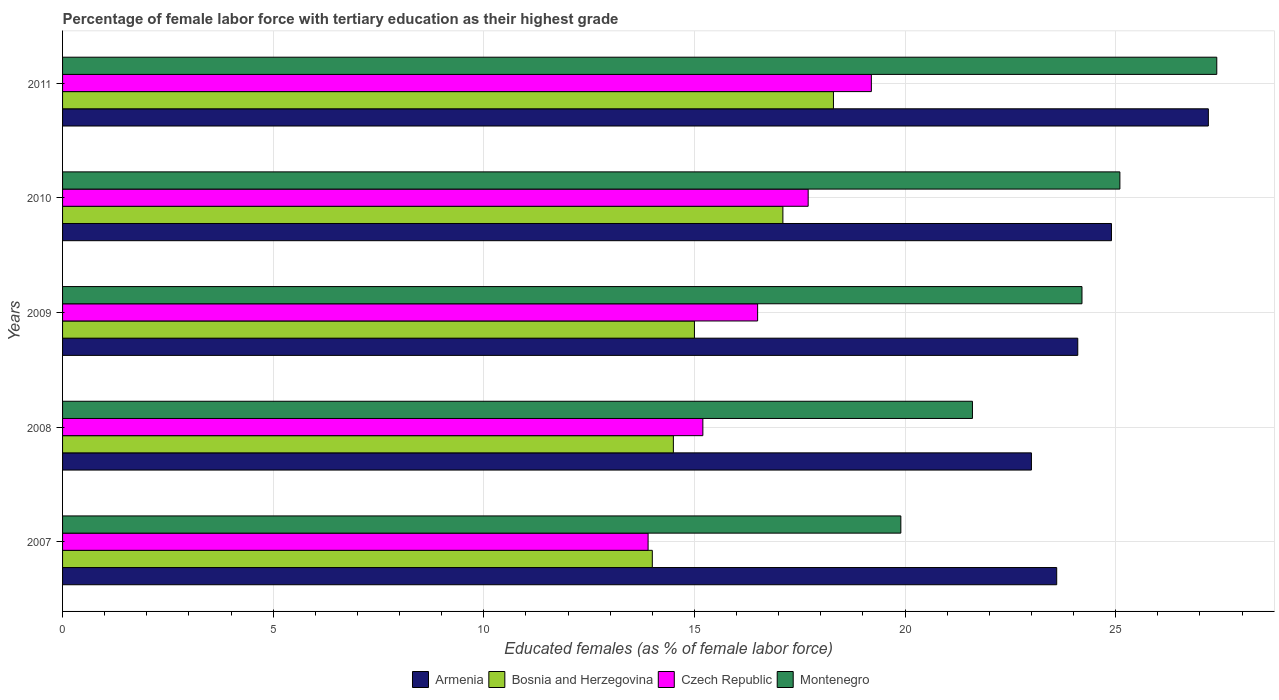How many different coloured bars are there?
Give a very brief answer. 4. What is the percentage of female labor force with tertiary education in Montenegro in 2009?
Offer a terse response. 24.2. Across all years, what is the maximum percentage of female labor force with tertiary education in Montenegro?
Your response must be concise. 27.4. In which year was the percentage of female labor force with tertiary education in Czech Republic maximum?
Make the answer very short. 2011. What is the total percentage of female labor force with tertiary education in Czech Republic in the graph?
Your response must be concise. 82.5. What is the average percentage of female labor force with tertiary education in Montenegro per year?
Your answer should be compact. 23.64. In the year 2011, what is the difference between the percentage of female labor force with tertiary education in Montenegro and percentage of female labor force with tertiary education in Armenia?
Offer a very short reply. 0.2. What is the ratio of the percentage of female labor force with tertiary education in Bosnia and Herzegovina in 2007 to that in 2011?
Keep it short and to the point. 0.77. What is the difference between the highest and the second highest percentage of female labor force with tertiary education in Bosnia and Herzegovina?
Your answer should be compact. 1.2. What is the difference between the highest and the lowest percentage of female labor force with tertiary education in Montenegro?
Make the answer very short. 7.5. In how many years, is the percentage of female labor force with tertiary education in Montenegro greater than the average percentage of female labor force with tertiary education in Montenegro taken over all years?
Ensure brevity in your answer.  3. Is it the case that in every year, the sum of the percentage of female labor force with tertiary education in Montenegro and percentage of female labor force with tertiary education in Czech Republic is greater than the sum of percentage of female labor force with tertiary education in Armenia and percentage of female labor force with tertiary education in Bosnia and Herzegovina?
Your answer should be compact. No. What does the 3rd bar from the top in 2010 represents?
Offer a terse response. Bosnia and Herzegovina. What does the 3rd bar from the bottom in 2011 represents?
Make the answer very short. Czech Republic. Are all the bars in the graph horizontal?
Your answer should be very brief. Yes. How many years are there in the graph?
Your response must be concise. 5. What is the difference between two consecutive major ticks on the X-axis?
Offer a very short reply. 5. Are the values on the major ticks of X-axis written in scientific E-notation?
Ensure brevity in your answer.  No. How many legend labels are there?
Provide a succinct answer. 4. How are the legend labels stacked?
Keep it short and to the point. Horizontal. What is the title of the graph?
Your answer should be compact. Percentage of female labor force with tertiary education as their highest grade. What is the label or title of the X-axis?
Provide a short and direct response. Educated females (as % of female labor force). What is the Educated females (as % of female labor force) of Armenia in 2007?
Provide a short and direct response. 23.6. What is the Educated females (as % of female labor force) of Czech Republic in 2007?
Keep it short and to the point. 13.9. What is the Educated females (as % of female labor force) in Montenegro in 2007?
Offer a terse response. 19.9. What is the Educated females (as % of female labor force) in Bosnia and Herzegovina in 2008?
Offer a very short reply. 14.5. What is the Educated females (as % of female labor force) in Czech Republic in 2008?
Provide a succinct answer. 15.2. What is the Educated females (as % of female labor force) of Montenegro in 2008?
Make the answer very short. 21.6. What is the Educated females (as % of female labor force) of Armenia in 2009?
Your answer should be very brief. 24.1. What is the Educated females (as % of female labor force) of Montenegro in 2009?
Keep it short and to the point. 24.2. What is the Educated females (as % of female labor force) in Armenia in 2010?
Provide a short and direct response. 24.9. What is the Educated females (as % of female labor force) in Bosnia and Herzegovina in 2010?
Your answer should be very brief. 17.1. What is the Educated females (as % of female labor force) in Czech Republic in 2010?
Offer a very short reply. 17.7. What is the Educated females (as % of female labor force) in Montenegro in 2010?
Ensure brevity in your answer.  25.1. What is the Educated females (as % of female labor force) in Armenia in 2011?
Your answer should be compact. 27.2. What is the Educated females (as % of female labor force) in Bosnia and Herzegovina in 2011?
Make the answer very short. 18.3. What is the Educated females (as % of female labor force) of Czech Republic in 2011?
Give a very brief answer. 19.2. What is the Educated females (as % of female labor force) in Montenegro in 2011?
Offer a terse response. 27.4. Across all years, what is the maximum Educated females (as % of female labor force) of Armenia?
Ensure brevity in your answer.  27.2. Across all years, what is the maximum Educated females (as % of female labor force) of Bosnia and Herzegovina?
Your answer should be very brief. 18.3. Across all years, what is the maximum Educated females (as % of female labor force) of Czech Republic?
Your answer should be compact. 19.2. Across all years, what is the maximum Educated females (as % of female labor force) of Montenegro?
Make the answer very short. 27.4. Across all years, what is the minimum Educated females (as % of female labor force) in Czech Republic?
Your response must be concise. 13.9. Across all years, what is the minimum Educated females (as % of female labor force) of Montenegro?
Provide a succinct answer. 19.9. What is the total Educated females (as % of female labor force) in Armenia in the graph?
Your response must be concise. 122.8. What is the total Educated females (as % of female labor force) in Bosnia and Herzegovina in the graph?
Your answer should be compact. 78.9. What is the total Educated females (as % of female labor force) of Czech Republic in the graph?
Provide a succinct answer. 82.5. What is the total Educated females (as % of female labor force) of Montenegro in the graph?
Your response must be concise. 118.2. What is the difference between the Educated females (as % of female labor force) of Bosnia and Herzegovina in 2007 and that in 2008?
Ensure brevity in your answer.  -0.5. What is the difference between the Educated females (as % of female labor force) in Montenegro in 2007 and that in 2008?
Provide a short and direct response. -1.7. What is the difference between the Educated females (as % of female labor force) in Czech Republic in 2007 and that in 2009?
Provide a short and direct response. -2.6. What is the difference between the Educated females (as % of female labor force) in Montenegro in 2007 and that in 2009?
Give a very brief answer. -4.3. What is the difference between the Educated females (as % of female labor force) in Bosnia and Herzegovina in 2007 and that in 2010?
Your answer should be compact. -3.1. What is the difference between the Educated females (as % of female labor force) in Montenegro in 2007 and that in 2010?
Your answer should be compact. -5.2. What is the difference between the Educated females (as % of female labor force) in Armenia in 2007 and that in 2011?
Give a very brief answer. -3.6. What is the difference between the Educated females (as % of female labor force) in Montenegro in 2007 and that in 2011?
Your response must be concise. -7.5. What is the difference between the Educated females (as % of female labor force) of Bosnia and Herzegovina in 2008 and that in 2009?
Ensure brevity in your answer.  -0.5. What is the difference between the Educated females (as % of female labor force) in Czech Republic in 2008 and that in 2009?
Your answer should be compact. -1.3. What is the difference between the Educated females (as % of female labor force) of Montenegro in 2008 and that in 2009?
Make the answer very short. -2.6. What is the difference between the Educated females (as % of female labor force) of Armenia in 2008 and that in 2010?
Offer a terse response. -1.9. What is the difference between the Educated females (as % of female labor force) in Bosnia and Herzegovina in 2008 and that in 2010?
Keep it short and to the point. -2.6. What is the difference between the Educated females (as % of female labor force) in Czech Republic in 2008 and that in 2010?
Provide a succinct answer. -2.5. What is the difference between the Educated females (as % of female labor force) in Montenegro in 2008 and that in 2010?
Your answer should be compact. -3.5. What is the difference between the Educated females (as % of female labor force) in Armenia in 2008 and that in 2011?
Offer a terse response. -4.2. What is the difference between the Educated females (as % of female labor force) in Armenia in 2009 and that in 2010?
Offer a terse response. -0.8. What is the difference between the Educated females (as % of female labor force) of Bosnia and Herzegovina in 2009 and that in 2010?
Ensure brevity in your answer.  -2.1. What is the difference between the Educated females (as % of female labor force) of Czech Republic in 2009 and that in 2010?
Your answer should be very brief. -1.2. What is the difference between the Educated females (as % of female labor force) of Armenia in 2009 and that in 2011?
Your response must be concise. -3.1. What is the difference between the Educated females (as % of female labor force) in Bosnia and Herzegovina in 2009 and that in 2011?
Your answer should be compact. -3.3. What is the difference between the Educated females (as % of female labor force) of Czech Republic in 2009 and that in 2011?
Offer a very short reply. -2.7. What is the difference between the Educated females (as % of female labor force) of Armenia in 2010 and that in 2011?
Keep it short and to the point. -2.3. What is the difference between the Educated females (as % of female labor force) of Bosnia and Herzegovina in 2010 and that in 2011?
Make the answer very short. -1.2. What is the difference between the Educated females (as % of female labor force) in Armenia in 2007 and the Educated females (as % of female labor force) in Bosnia and Herzegovina in 2008?
Offer a very short reply. 9.1. What is the difference between the Educated females (as % of female labor force) in Armenia in 2007 and the Educated females (as % of female labor force) in Bosnia and Herzegovina in 2009?
Make the answer very short. 8.6. What is the difference between the Educated females (as % of female labor force) in Armenia in 2007 and the Educated females (as % of female labor force) in Montenegro in 2009?
Provide a short and direct response. -0.6. What is the difference between the Educated females (as % of female labor force) of Bosnia and Herzegovina in 2007 and the Educated females (as % of female labor force) of Czech Republic in 2009?
Keep it short and to the point. -2.5. What is the difference between the Educated females (as % of female labor force) in Czech Republic in 2007 and the Educated females (as % of female labor force) in Montenegro in 2009?
Make the answer very short. -10.3. What is the difference between the Educated females (as % of female labor force) in Armenia in 2007 and the Educated females (as % of female labor force) in Czech Republic in 2010?
Give a very brief answer. 5.9. What is the difference between the Educated females (as % of female labor force) in Armenia in 2007 and the Educated females (as % of female labor force) in Montenegro in 2010?
Give a very brief answer. -1.5. What is the difference between the Educated females (as % of female labor force) in Czech Republic in 2007 and the Educated females (as % of female labor force) in Montenegro in 2010?
Ensure brevity in your answer.  -11.2. What is the difference between the Educated females (as % of female labor force) of Armenia in 2007 and the Educated females (as % of female labor force) of Czech Republic in 2011?
Make the answer very short. 4.4. What is the difference between the Educated females (as % of female labor force) in Bosnia and Herzegovina in 2007 and the Educated females (as % of female labor force) in Montenegro in 2011?
Make the answer very short. -13.4. What is the difference between the Educated females (as % of female labor force) in Czech Republic in 2007 and the Educated females (as % of female labor force) in Montenegro in 2011?
Provide a short and direct response. -13.5. What is the difference between the Educated females (as % of female labor force) of Bosnia and Herzegovina in 2008 and the Educated females (as % of female labor force) of Czech Republic in 2009?
Provide a succinct answer. -2. What is the difference between the Educated females (as % of female labor force) in Armenia in 2008 and the Educated females (as % of female labor force) in Montenegro in 2010?
Offer a very short reply. -2.1. What is the difference between the Educated females (as % of female labor force) of Bosnia and Herzegovina in 2008 and the Educated females (as % of female labor force) of Czech Republic in 2010?
Provide a succinct answer. -3.2. What is the difference between the Educated females (as % of female labor force) of Czech Republic in 2008 and the Educated females (as % of female labor force) of Montenegro in 2010?
Provide a short and direct response. -9.9. What is the difference between the Educated females (as % of female labor force) in Armenia in 2008 and the Educated females (as % of female labor force) in Bosnia and Herzegovina in 2011?
Make the answer very short. 4.7. What is the difference between the Educated females (as % of female labor force) of Armenia in 2008 and the Educated females (as % of female labor force) of Czech Republic in 2011?
Your response must be concise. 3.8. What is the difference between the Educated females (as % of female labor force) of Bosnia and Herzegovina in 2008 and the Educated females (as % of female labor force) of Czech Republic in 2011?
Provide a short and direct response. -4.7. What is the difference between the Educated females (as % of female labor force) of Armenia in 2009 and the Educated females (as % of female labor force) of Czech Republic in 2010?
Your response must be concise. 6.4. What is the difference between the Educated females (as % of female labor force) of Armenia in 2009 and the Educated females (as % of female labor force) of Montenegro in 2010?
Provide a succinct answer. -1. What is the difference between the Educated females (as % of female labor force) in Bosnia and Herzegovina in 2009 and the Educated females (as % of female labor force) in Montenegro in 2010?
Give a very brief answer. -10.1. What is the difference between the Educated females (as % of female labor force) of Czech Republic in 2009 and the Educated females (as % of female labor force) of Montenegro in 2010?
Your response must be concise. -8.6. What is the difference between the Educated females (as % of female labor force) in Armenia in 2009 and the Educated females (as % of female labor force) in Czech Republic in 2011?
Offer a terse response. 4.9. What is the difference between the Educated females (as % of female labor force) in Bosnia and Herzegovina in 2009 and the Educated females (as % of female labor force) in Czech Republic in 2011?
Your response must be concise. -4.2. What is the difference between the Educated females (as % of female labor force) of Armenia in 2010 and the Educated females (as % of female labor force) of Bosnia and Herzegovina in 2011?
Ensure brevity in your answer.  6.6. What is the difference between the Educated females (as % of female labor force) in Armenia in 2010 and the Educated females (as % of female labor force) in Czech Republic in 2011?
Ensure brevity in your answer.  5.7. What is the difference between the Educated females (as % of female labor force) of Armenia in 2010 and the Educated females (as % of female labor force) of Montenegro in 2011?
Offer a terse response. -2.5. What is the difference between the Educated females (as % of female labor force) of Czech Republic in 2010 and the Educated females (as % of female labor force) of Montenegro in 2011?
Your answer should be compact. -9.7. What is the average Educated females (as % of female labor force) in Armenia per year?
Offer a very short reply. 24.56. What is the average Educated females (as % of female labor force) in Bosnia and Herzegovina per year?
Ensure brevity in your answer.  15.78. What is the average Educated females (as % of female labor force) of Czech Republic per year?
Give a very brief answer. 16.5. What is the average Educated females (as % of female labor force) of Montenegro per year?
Make the answer very short. 23.64. In the year 2008, what is the difference between the Educated females (as % of female labor force) in Armenia and Educated females (as % of female labor force) in Bosnia and Herzegovina?
Offer a very short reply. 8.5. In the year 2008, what is the difference between the Educated females (as % of female labor force) of Armenia and Educated females (as % of female labor force) of Czech Republic?
Your answer should be compact. 7.8. In the year 2008, what is the difference between the Educated females (as % of female labor force) in Armenia and Educated females (as % of female labor force) in Montenegro?
Make the answer very short. 1.4. In the year 2008, what is the difference between the Educated females (as % of female labor force) of Bosnia and Herzegovina and Educated females (as % of female labor force) of Czech Republic?
Make the answer very short. -0.7. In the year 2008, what is the difference between the Educated females (as % of female labor force) in Bosnia and Herzegovina and Educated females (as % of female labor force) in Montenegro?
Your response must be concise. -7.1. In the year 2009, what is the difference between the Educated females (as % of female labor force) in Armenia and Educated females (as % of female labor force) in Czech Republic?
Make the answer very short. 7.6. In the year 2009, what is the difference between the Educated females (as % of female labor force) of Czech Republic and Educated females (as % of female labor force) of Montenegro?
Provide a succinct answer. -7.7. In the year 2010, what is the difference between the Educated females (as % of female labor force) in Armenia and Educated females (as % of female labor force) in Bosnia and Herzegovina?
Ensure brevity in your answer.  7.8. In the year 2010, what is the difference between the Educated females (as % of female labor force) of Armenia and Educated females (as % of female labor force) of Montenegro?
Give a very brief answer. -0.2. In the year 2010, what is the difference between the Educated females (as % of female labor force) in Bosnia and Herzegovina and Educated females (as % of female labor force) in Montenegro?
Offer a terse response. -8. In the year 2011, what is the difference between the Educated females (as % of female labor force) of Armenia and Educated females (as % of female labor force) of Montenegro?
Make the answer very short. -0.2. What is the ratio of the Educated females (as % of female labor force) in Armenia in 2007 to that in 2008?
Make the answer very short. 1.03. What is the ratio of the Educated females (as % of female labor force) in Bosnia and Herzegovina in 2007 to that in 2008?
Provide a short and direct response. 0.97. What is the ratio of the Educated females (as % of female labor force) of Czech Republic in 2007 to that in 2008?
Offer a terse response. 0.91. What is the ratio of the Educated females (as % of female labor force) in Montenegro in 2007 to that in 2008?
Ensure brevity in your answer.  0.92. What is the ratio of the Educated females (as % of female labor force) in Armenia in 2007 to that in 2009?
Ensure brevity in your answer.  0.98. What is the ratio of the Educated females (as % of female labor force) in Bosnia and Herzegovina in 2007 to that in 2009?
Make the answer very short. 0.93. What is the ratio of the Educated females (as % of female labor force) in Czech Republic in 2007 to that in 2009?
Your response must be concise. 0.84. What is the ratio of the Educated females (as % of female labor force) of Montenegro in 2007 to that in 2009?
Your response must be concise. 0.82. What is the ratio of the Educated females (as % of female labor force) of Armenia in 2007 to that in 2010?
Ensure brevity in your answer.  0.95. What is the ratio of the Educated females (as % of female labor force) in Bosnia and Herzegovina in 2007 to that in 2010?
Your response must be concise. 0.82. What is the ratio of the Educated females (as % of female labor force) of Czech Republic in 2007 to that in 2010?
Your answer should be very brief. 0.79. What is the ratio of the Educated females (as % of female labor force) in Montenegro in 2007 to that in 2010?
Your answer should be compact. 0.79. What is the ratio of the Educated females (as % of female labor force) of Armenia in 2007 to that in 2011?
Your response must be concise. 0.87. What is the ratio of the Educated females (as % of female labor force) in Bosnia and Herzegovina in 2007 to that in 2011?
Your answer should be very brief. 0.77. What is the ratio of the Educated females (as % of female labor force) in Czech Republic in 2007 to that in 2011?
Your answer should be very brief. 0.72. What is the ratio of the Educated females (as % of female labor force) of Montenegro in 2007 to that in 2011?
Provide a succinct answer. 0.73. What is the ratio of the Educated females (as % of female labor force) of Armenia in 2008 to that in 2009?
Make the answer very short. 0.95. What is the ratio of the Educated females (as % of female labor force) of Bosnia and Herzegovina in 2008 to that in 2009?
Provide a succinct answer. 0.97. What is the ratio of the Educated females (as % of female labor force) of Czech Republic in 2008 to that in 2009?
Keep it short and to the point. 0.92. What is the ratio of the Educated females (as % of female labor force) in Montenegro in 2008 to that in 2009?
Offer a very short reply. 0.89. What is the ratio of the Educated females (as % of female labor force) of Armenia in 2008 to that in 2010?
Your answer should be very brief. 0.92. What is the ratio of the Educated females (as % of female labor force) of Bosnia and Herzegovina in 2008 to that in 2010?
Your answer should be very brief. 0.85. What is the ratio of the Educated females (as % of female labor force) of Czech Republic in 2008 to that in 2010?
Keep it short and to the point. 0.86. What is the ratio of the Educated females (as % of female labor force) of Montenegro in 2008 to that in 2010?
Ensure brevity in your answer.  0.86. What is the ratio of the Educated females (as % of female labor force) of Armenia in 2008 to that in 2011?
Offer a very short reply. 0.85. What is the ratio of the Educated females (as % of female labor force) in Bosnia and Herzegovina in 2008 to that in 2011?
Your answer should be very brief. 0.79. What is the ratio of the Educated females (as % of female labor force) in Czech Republic in 2008 to that in 2011?
Keep it short and to the point. 0.79. What is the ratio of the Educated females (as % of female labor force) in Montenegro in 2008 to that in 2011?
Offer a terse response. 0.79. What is the ratio of the Educated females (as % of female labor force) in Armenia in 2009 to that in 2010?
Provide a short and direct response. 0.97. What is the ratio of the Educated females (as % of female labor force) of Bosnia and Herzegovina in 2009 to that in 2010?
Make the answer very short. 0.88. What is the ratio of the Educated females (as % of female labor force) of Czech Republic in 2009 to that in 2010?
Your response must be concise. 0.93. What is the ratio of the Educated females (as % of female labor force) in Montenegro in 2009 to that in 2010?
Provide a succinct answer. 0.96. What is the ratio of the Educated females (as % of female labor force) in Armenia in 2009 to that in 2011?
Your response must be concise. 0.89. What is the ratio of the Educated females (as % of female labor force) in Bosnia and Herzegovina in 2009 to that in 2011?
Keep it short and to the point. 0.82. What is the ratio of the Educated females (as % of female labor force) of Czech Republic in 2009 to that in 2011?
Give a very brief answer. 0.86. What is the ratio of the Educated females (as % of female labor force) in Montenegro in 2009 to that in 2011?
Your response must be concise. 0.88. What is the ratio of the Educated females (as % of female labor force) in Armenia in 2010 to that in 2011?
Ensure brevity in your answer.  0.92. What is the ratio of the Educated females (as % of female labor force) in Bosnia and Herzegovina in 2010 to that in 2011?
Provide a short and direct response. 0.93. What is the ratio of the Educated females (as % of female labor force) of Czech Republic in 2010 to that in 2011?
Offer a very short reply. 0.92. What is the ratio of the Educated females (as % of female labor force) of Montenegro in 2010 to that in 2011?
Provide a short and direct response. 0.92. What is the difference between the highest and the second highest Educated females (as % of female labor force) in Czech Republic?
Give a very brief answer. 1.5. What is the difference between the highest and the second highest Educated females (as % of female labor force) of Montenegro?
Ensure brevity in your answer.  2.3. What is the difference between the highest and the lowest Educated females (as % of female labor force) in Armenia?
Ensure brevity in your answer.  4.2. What is the difference between the highest and the lowest Educated females (as % of female labor force) of Czech Republic?
Offer a terse response. 5.3. What is the difference between the highest and the lowest Educated females (as % of female labor force) in Montenegro?
Offer a terse response. 7.5. 